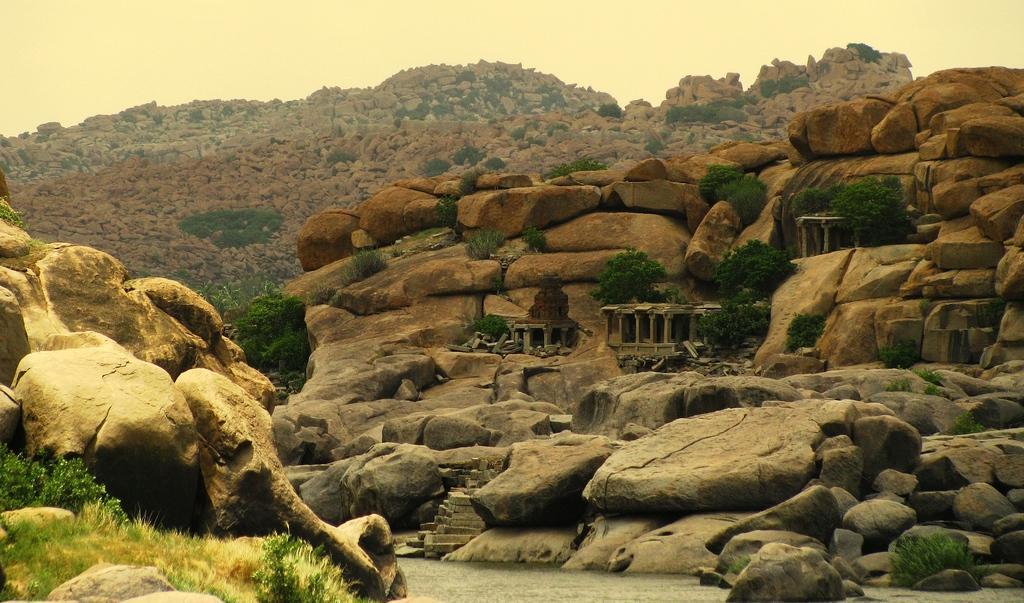Please provide a concise description of this image. In the image there are hills and mountains, in between the hills there are trees and plants. 